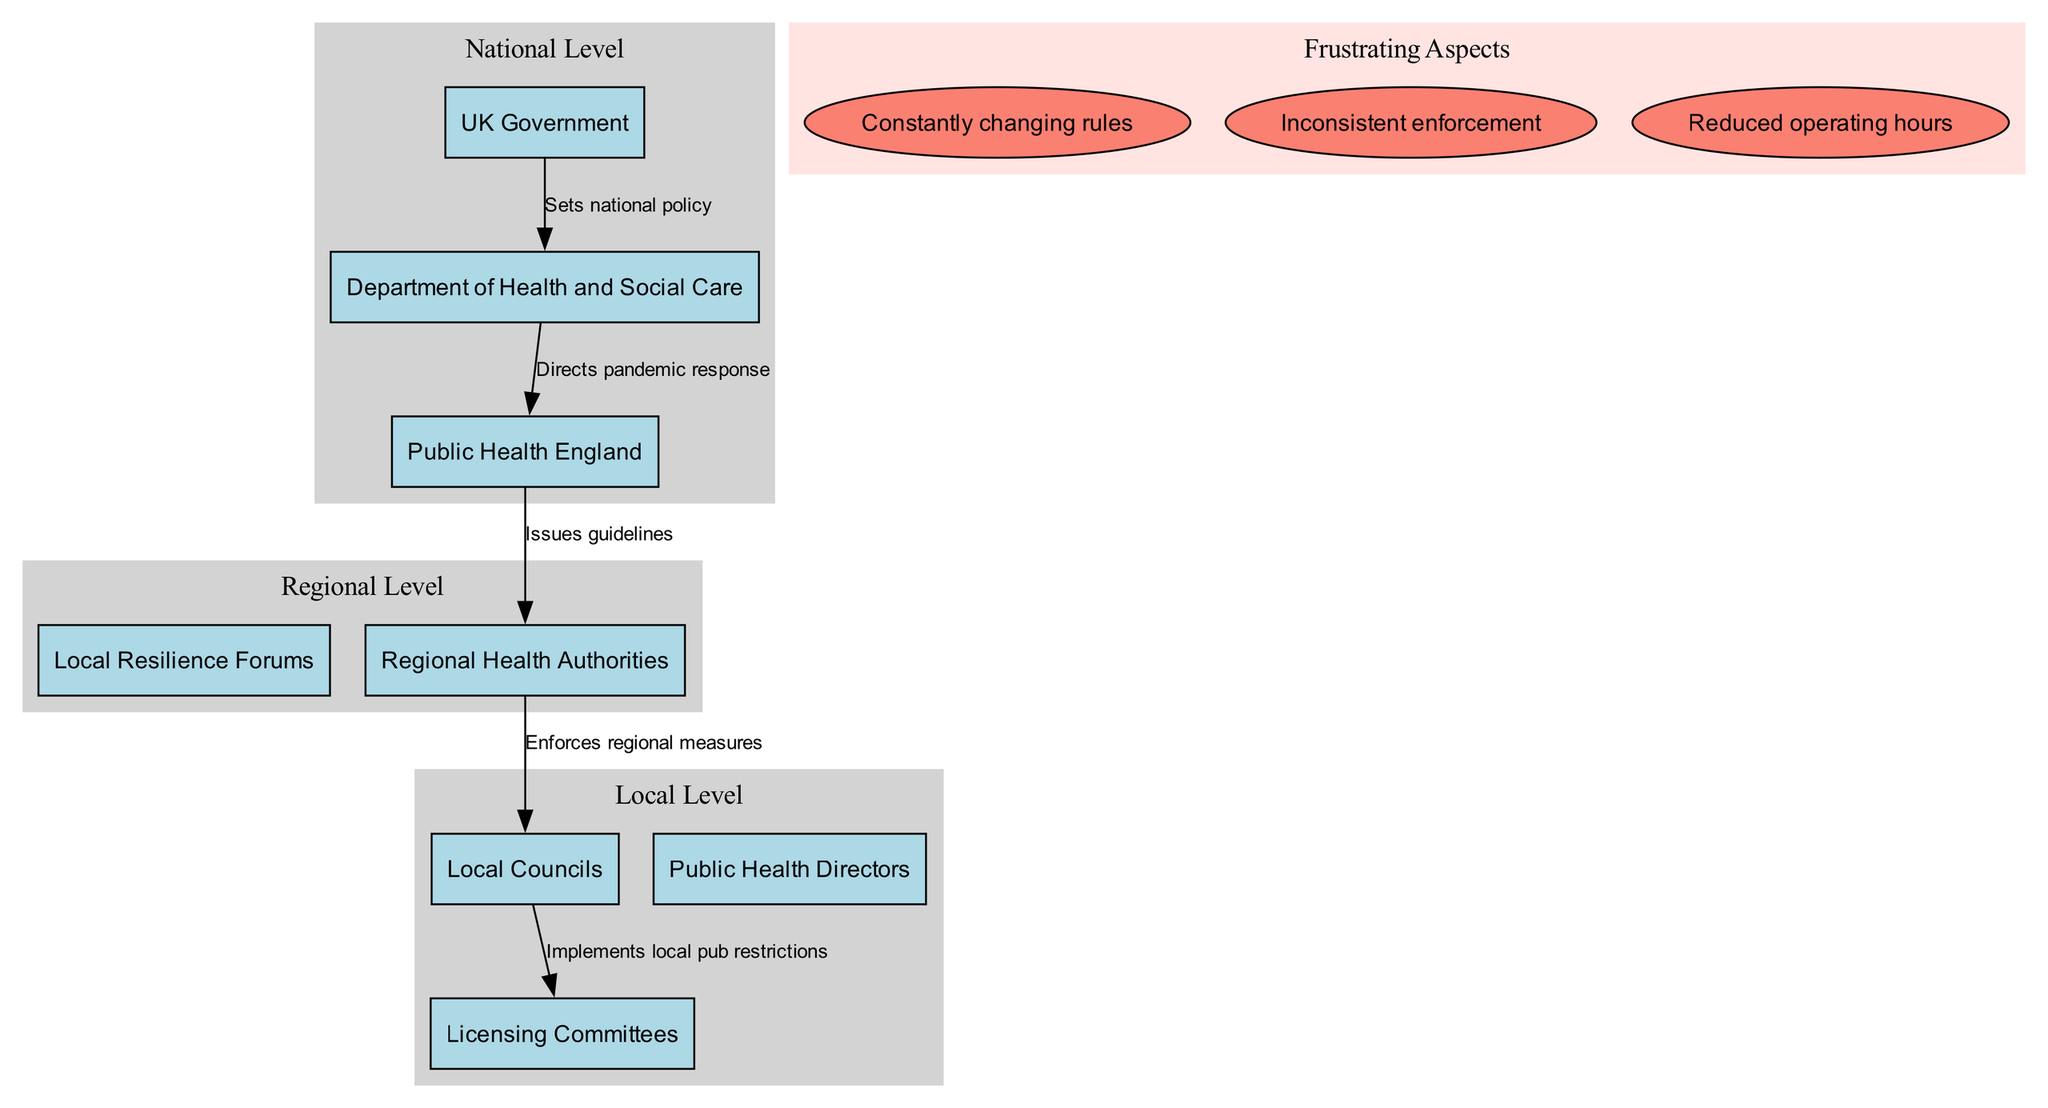What is the top entity at the National Level? The diagram indicates that the top entity at the National Level is the UK Government. It is placed at the top of the hierarchy, as shown in the National Level section of the diagram.
Answer: UK Government How many entities are present at the Local Level? In the diagram, the Local Level lists three entities: Local Councils, Public Health Directors, and Licensing Committees. Since the diagram shows all these entities, it is clear there are three.
Answer: 3 Who directs the pandemic response? According to the diagram, the Department of Health and Social Care is responsible for directing the pandemic response. This is indicated by the connection from this department to Public Health England, labeled accordingly.
Answer: Department of Health and Social Care What is the function of Public Health England in the hierarchy? Public Health England issues guidelines to Regional Health Authorities, playing a critical role in the flow of information and regulations in the hierarchy as indicated by the connection in the diagram.
Answer: Issues guidelines Which level enforces regional measures? The diagram shows that Regional Health Authorities enforce regional measures, as indicated by the direct connection to Local Councils. This clarifies the responsibility of this entity within the regional governmental structure.
Answer: Regional Health Authorities What is the relationship between Local Councils and Licensing Committees? The relationship is that Local Councils implement local pub restrictions through Licensing Committees, as detailed in the connecting arrow between these two entities in the diagram.
Answer: Implements local pub restrictions In total, how many frustrating aspects are identified in the diagram? The diagram lists three frustrating aspects concerning the pub regulations during the pandemic. This is confirmed by counting each unique frustration displayed within the Frustrating Aspects cluster.
Answer: 3 What specific frustrating aspect mentions inconsistent enforcement? The frustrating aspect regarding inconsistent enforcement is explicitly noted in the diagram as one of the frustrations faced during the pandemic, emphasizing the challenges within the regulatory framework.
Answer: Inconsistent enforcement What does the UK Government set at the national level? The UK Government sets national policy, which is prominently displayed in the diagram as the first connection within the National Level, outlining its primary role in the hierarchical structure.
Answer: National policy What cluster color represents Frustrating Aspects? The color used to represent the Frustrating Aspects cluster in the diagram is mistyrose, as shown in the attributes where this cluster is defined.
Answer: Mistyrose 